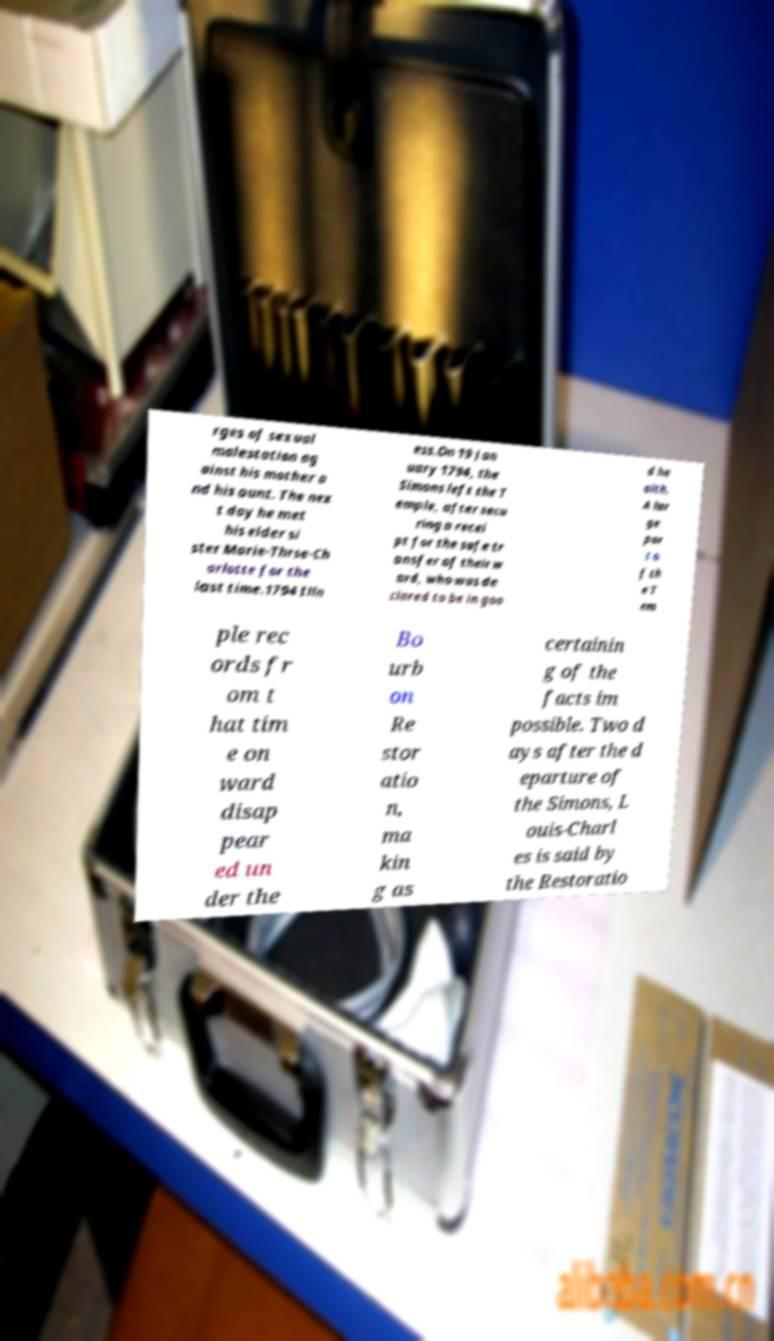Can you read and provide the text displayed in the image?This photo seems to have some interesting text. Can you extract and type it out for me? rges of sexual molestation ag ainst his mother a nd his aunt. The nex t day he met his elder si ster Marie-Thrse-Ch arlotte for the last time.1794 Illn ess.On 19 Jan uary 1794, the Simons left the T emple, after secu ring a recei pt for the safe tr ansfer of their w ard, who was de clared to be in goo d he alth. A lar ge par t o f th e T em ple rec ords fr om t hat tim e on ward disap pear ed un der the Bo urb on Re stor atio n, ma kin g as certainin g of the facts im possible. Two d ays after the d eparture of the Simons, L ouis-Charl es is said by the Restoratio 